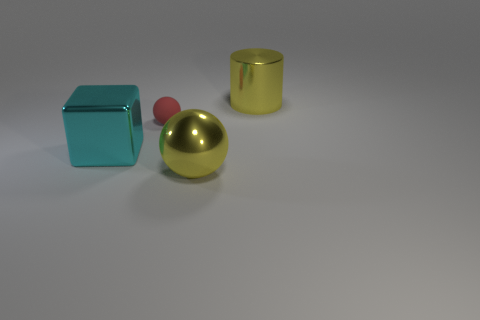There is a large yellow object that is to the left of the large yellow metallic cylinder; what is it made of? The object in question appears to be a yellow, spherical shape made of a material with metallic properties, reflecting light and exhibiting a shiny surface. This suggests it could be composed of a polished metal, possibly a type of steel or aluminum alloy, commonly used in decorative objects. 